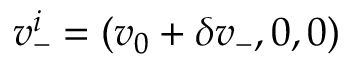<formula> <loc_0><loc_0><loc_500><loc_500>v _ { - } ^ { i } = ( v _ { 0 } + \delta v _ { - } , 0 , 0 )</formula> 